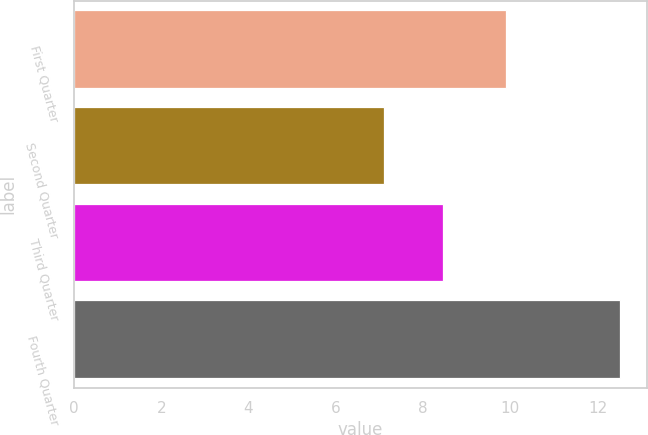Convert chart to OTSL. <chart><loc_0><loc_0><loc_500><loc_500><bar_chart><fcel>First Quarter<fcel>Second Quarter<fcel>Third Quarter<fcel>Fourth Quarter<nl><fcel>9.9<fcel>7.1<fcel>8.45<fcel>12.5<nl></chart> 